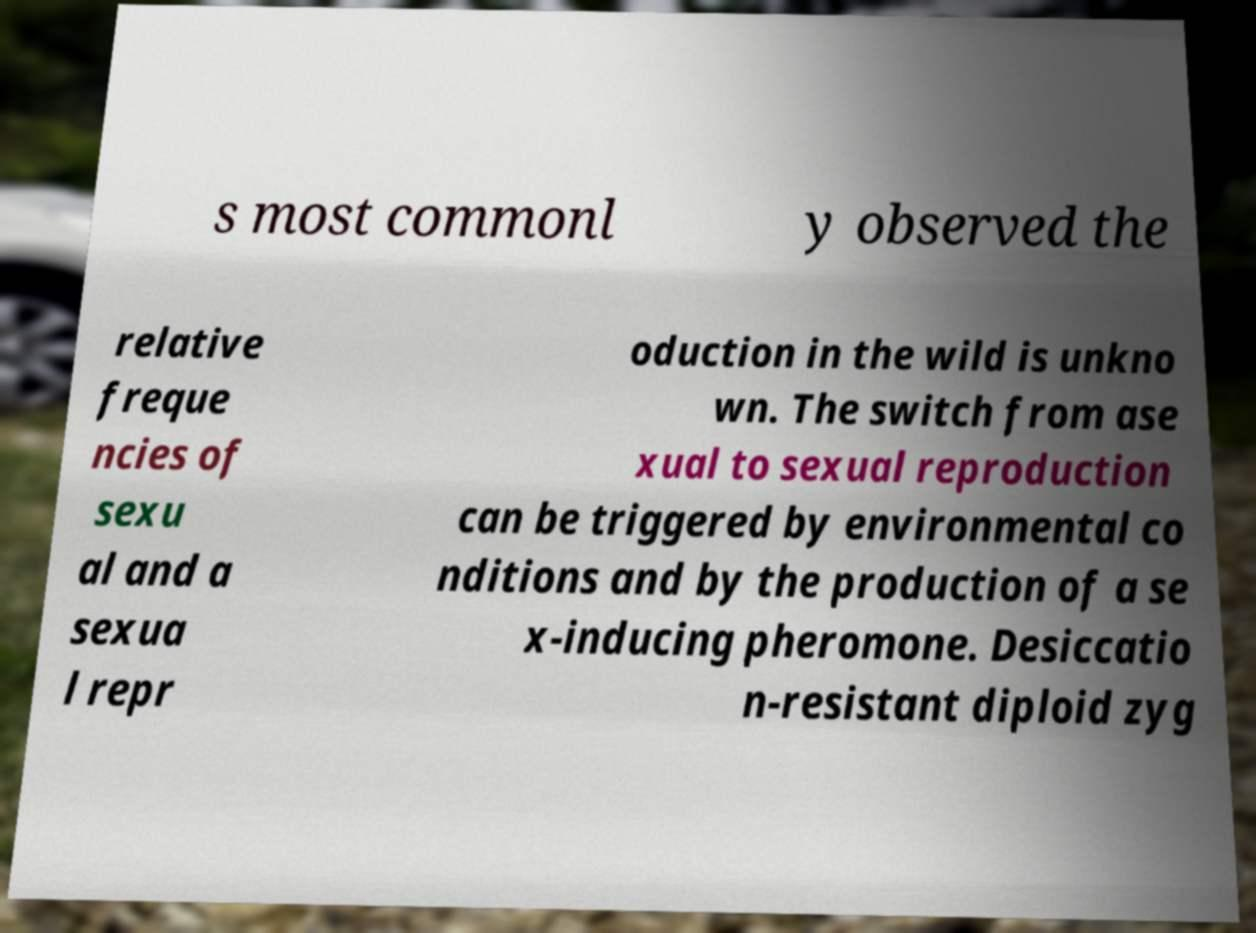Can you accurately transcribe the text from the provided image for me? s most commonl y observed the relative freque ncies of sexu al and a sexua l repr oduction in the wild is unkno wn. The switch from ase xual to sexual reproduction can be triggered by environmental co nditions and by the production of a se x-inducing pheromone. Desiccatio n-resistant diploid zyg 